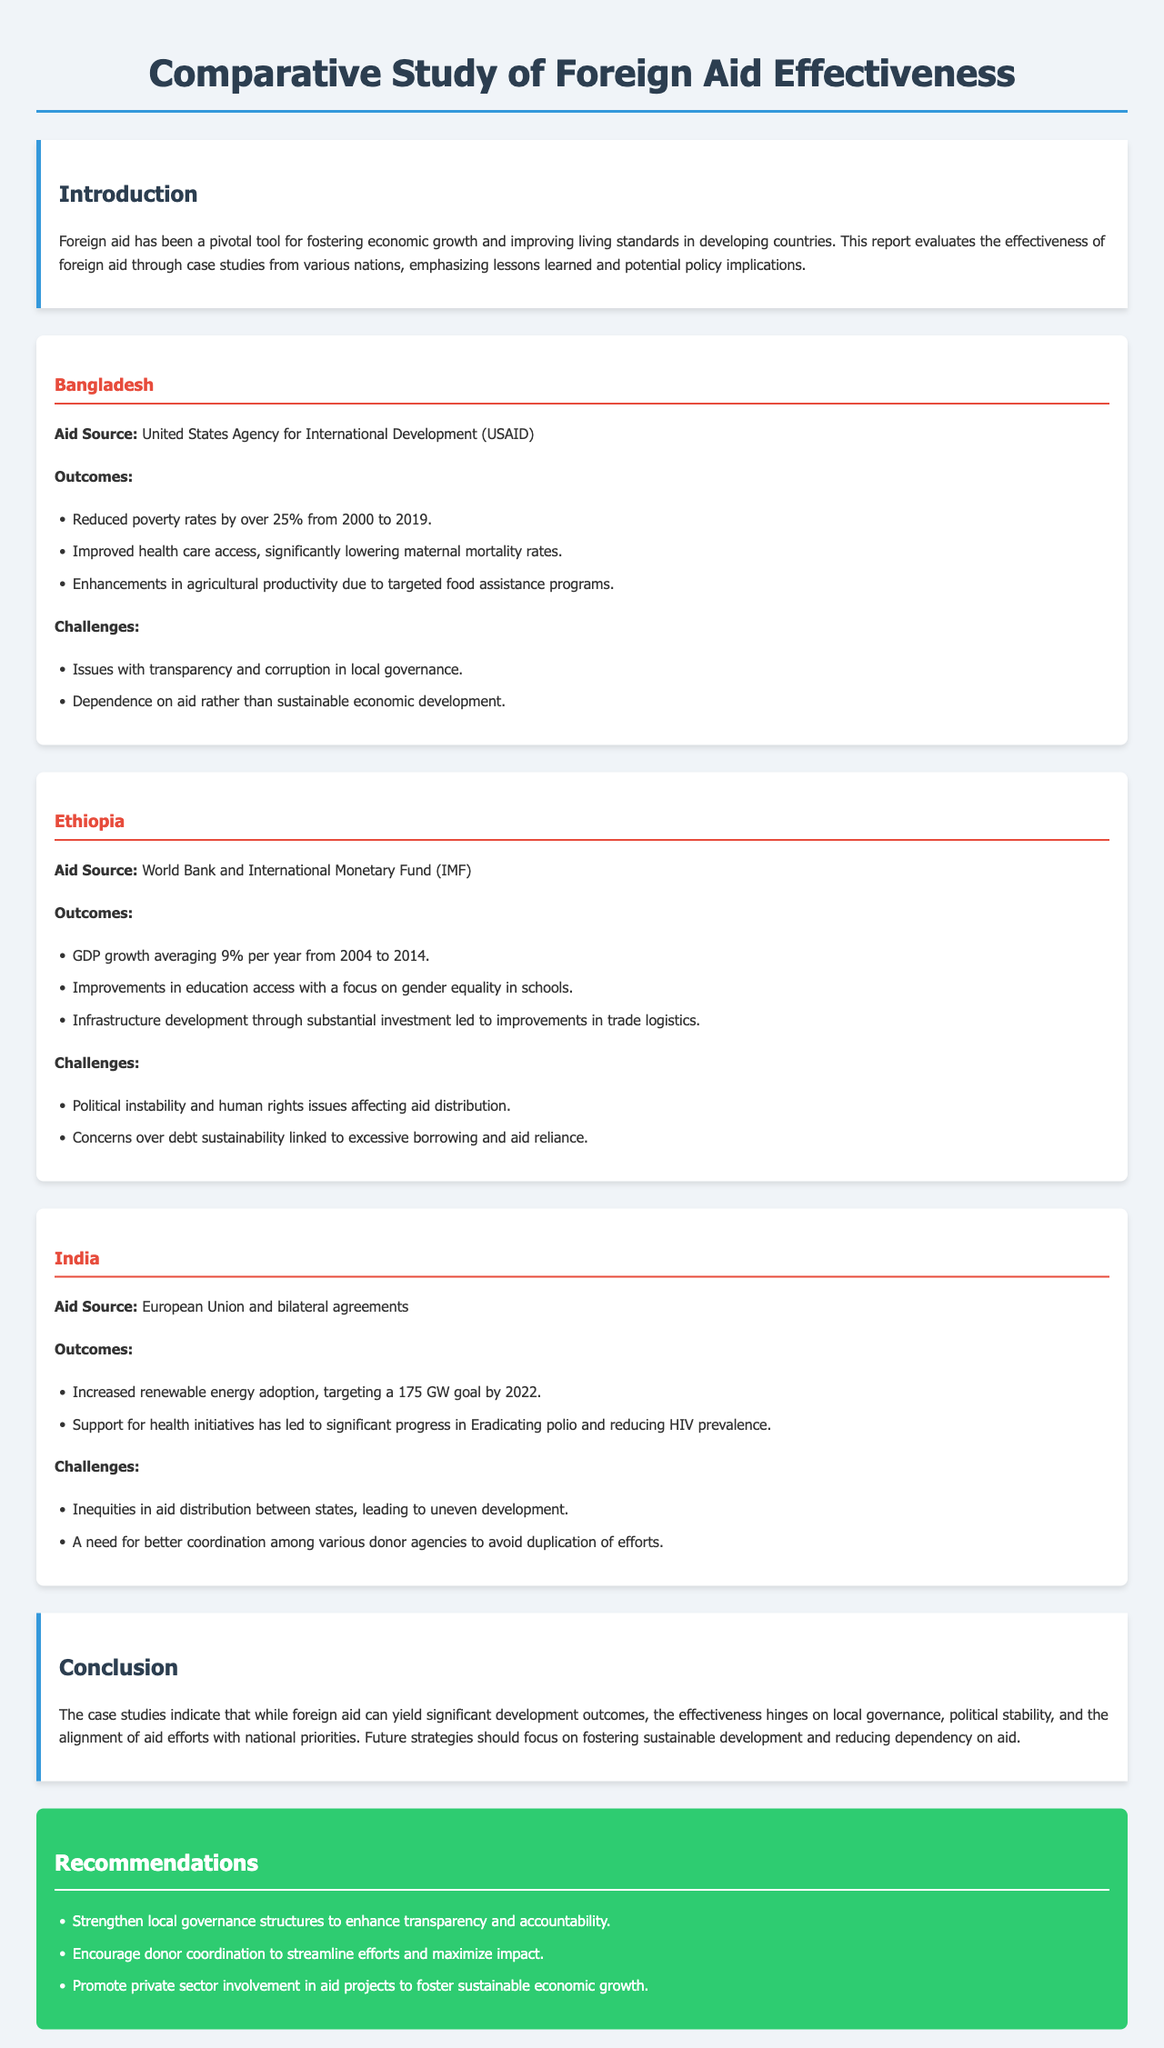What is the main source of aid for Bangladesh? The main source of aid for Bangladesh mentioned in the document is from the United States Agency for International Development.
Answer: United States Agency for International Development What was the GDP growth rate in Ethiopia from 2004 to 2014? The document states that GDP growth in Ethiopia averaged 9% per year during this period.
Answer: 9% What significant health improvement was noted as an outcome of aid in India? Aid in India has led to significant progress in eradicating polio and reducing HIV prevalence.
Answer: Eradicating polio and reducing HIV prevalence Which country had improvements in agricultural productivity due to targeted food assistance? The case study for Bangladesh indicated enhancements in agricultural productivity due to targeted food assistance programs.
Answer: Bangladesh What are the two main challenges reported for Ethiopia? The document lists political instability and human rights issues, as well as concerns over debt sustainability.
Answer: Political instability and human rights issues What should future strategies focus on according to the conclusion? The conclusion of the report suggests that future strategies should emphasize fostering sustainable development and reducing dependency on aid.
Answer: Fostering sustainable development and reducing dependency on aid What type of organizations provided aid to India? Aid to India was sourced from the European Union and bilateral agreements.
Answer: European Union and bilateral agreements How many recommendations are provided at the end of the report? The document lists three recommendations at the end of the report.
Answer: Three 